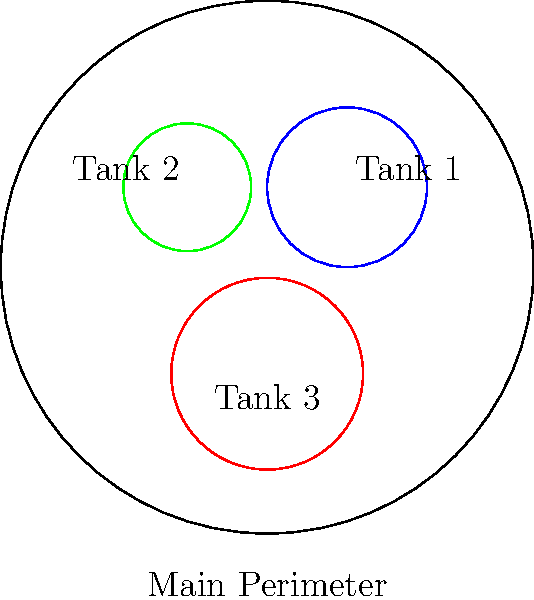A circular storage tank farm contains three tanks of varying diameters. The farm's perimeter is enclosed by a circular fence with a radius of 5 units. Inside, there are three tanks with radii of 1.5, 1.2, and 1.8 units respectively. What is the total perimeter of all circular structures (the outer fence and the three tanks) in this storage facility? To solve this problem, we need to calculate the circumference of the outer fence and each tank, then sum them up. Let's break it down step-by-step:

1. Calculate the circumference of the outer fence:
   Circumference = $2\pi r$, where $r$ is the radius
   Outer fence circumference = $2\pi \cdot 5 = 10\pi$ units

2. Calculate the circumference of Tank 1:
   Tank 1 circumference = $2\pi \cdot 1.5 = 3\pi$ units

3. Calculate the circumference of Tank 2:
   Tank 2 circumference = $2\pi \cdot 1.2 = 2.4\pi$ units

4. Calculate the circumference of Tank 3:
   Tank 3 circumference = $2\pi \cdot 1.8 = 3.6\pi$ units

5. Sum up all the circumferences:
   Total perimeter = Outer fence + Tank 1 + Tank 2 + Tank 3
   Total perimeter = $10\pi + 3\pi + 2.4\pi + 3.6\pi = 19\pi$ units

Therefore, the total perimeter of all circular structures in the storage facility is $19\pi$ units.
Answer: $19\pi$ units 